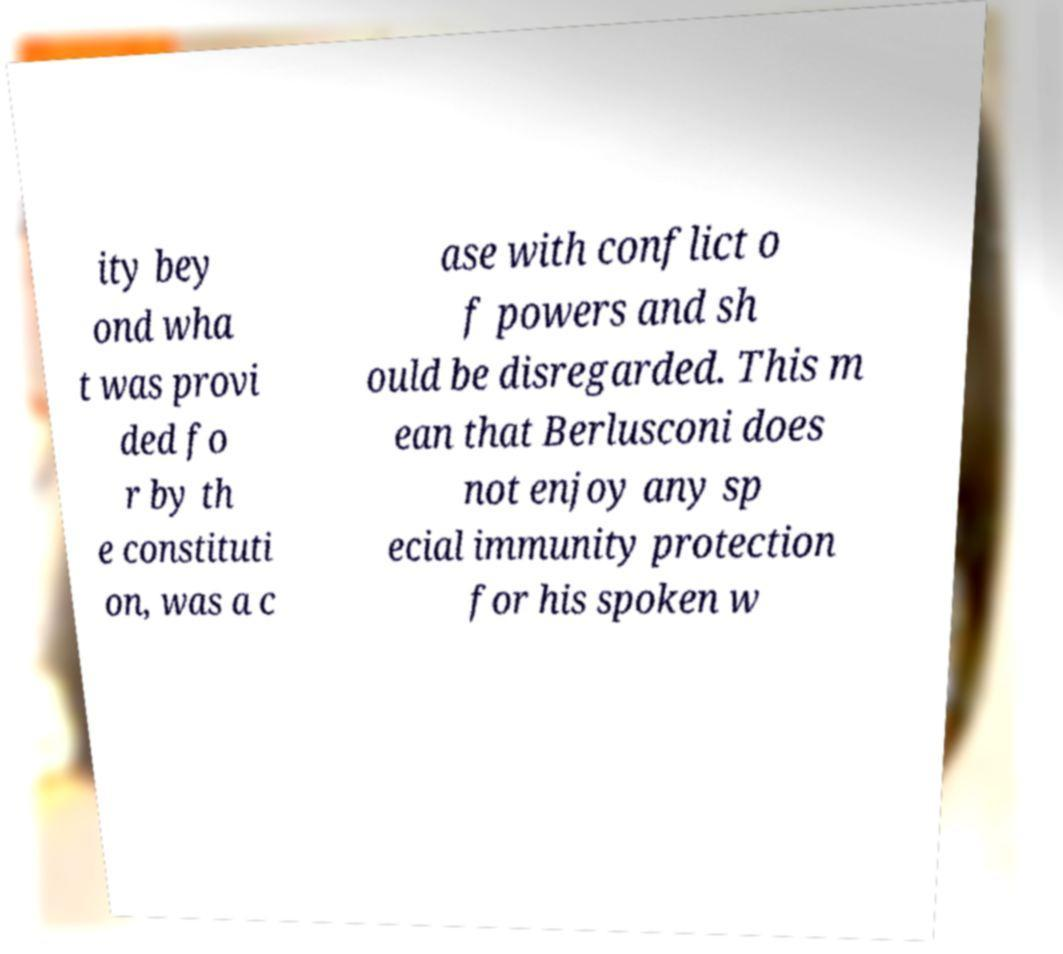For documentation purposes, I need the text within this image transcribed. Could you provide that? ity bey ond wha t was provi ded fo r by th e constituti on, was a c ase with conflict o f powers and sh ould be disregarded. This m ean that Berlusconi does not enjoy any sp ecial immunity protection for his spoken w 